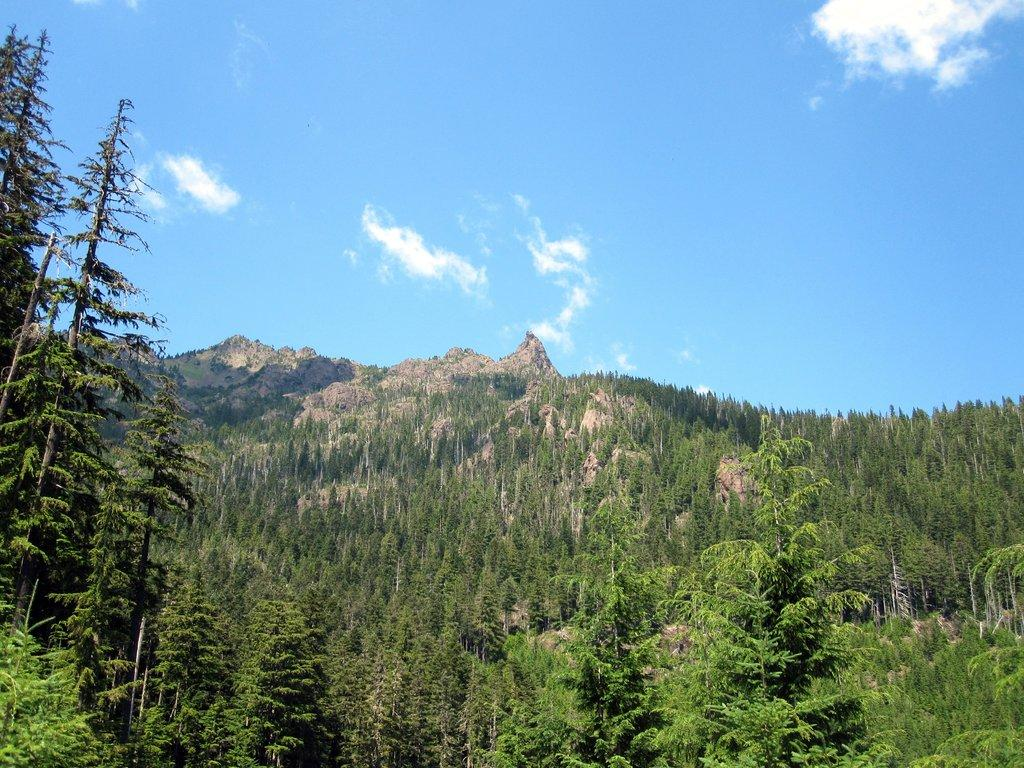What type of vegetation can be seen in the image? There are trees and plants in the image. What natural feature is visible in the background of the image? There are mountains visible in the image. What time is displayed on the clock in the image? There is no clock present in the image. What type of base is supporting the trees in the image? The trees in the image are growing naturally and do not require a base for support. 